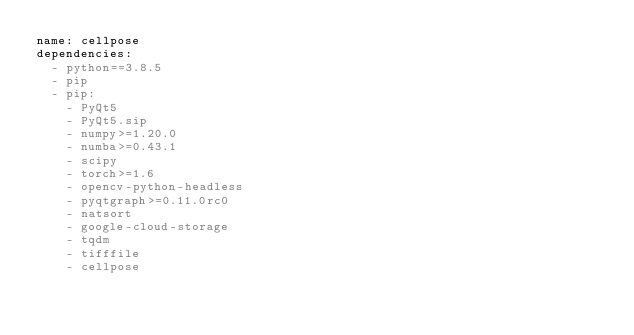<code> <loc_0><loc_0><loc_500><loc_500><_YAML_>name: cellpose
dependencies:
  - python==3.8.5
  - pip
  - pip:
    - PyQt5
    - PyQt5.sip
    - numpy>=1.20.0
    - numba>=0.43.1
    - scipy
    - torch>=1.6
    - opencv-python-headless
    - pyqtgraph>=0.11.0rc0
    - natsort
    - google-cloud-storage
    - tqdm
    - tifffile
    - cellpose
    
  
</code> 